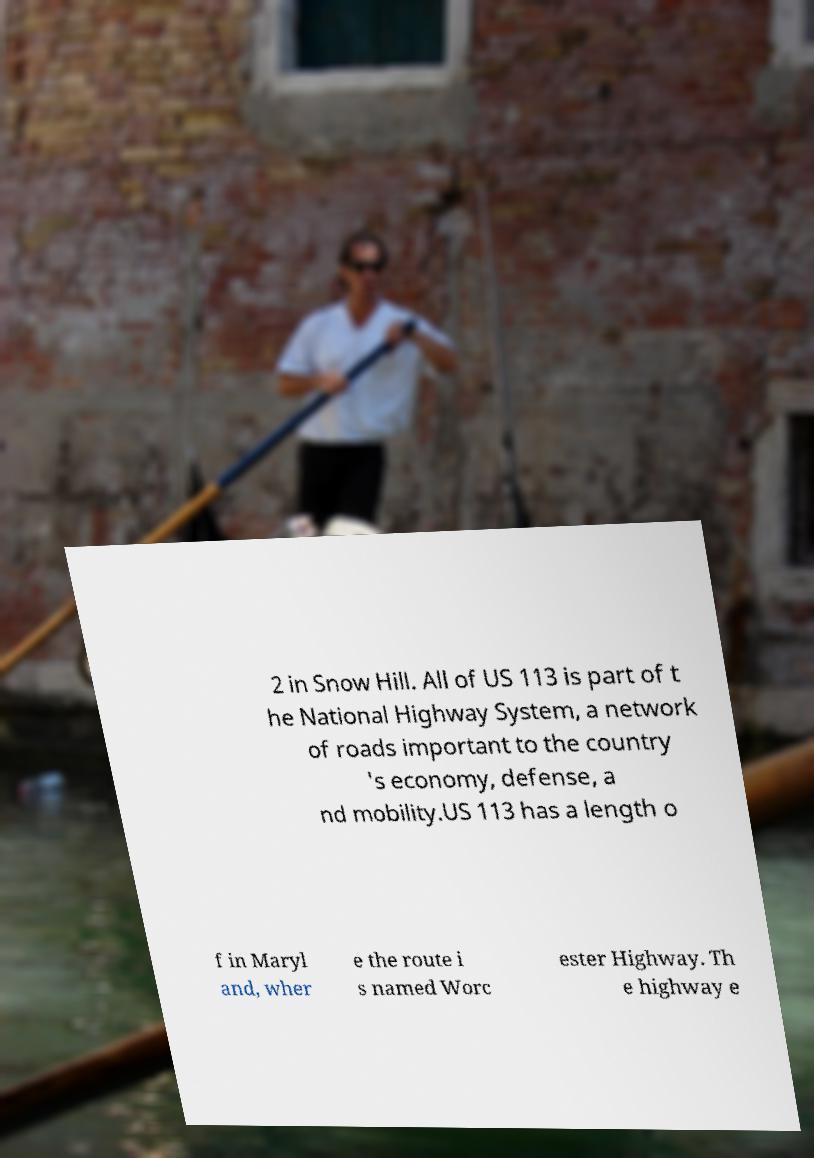Could you extract and type out the text from this image? 2 in Snow Hill. All of US 113 is part of t he National Highway System, a network of roads important to the country 's economy, defense, a nd mobility.US 113 has a length o f in Maryl and, wher e the route i s named Worc ester Highway. Th e highway e 